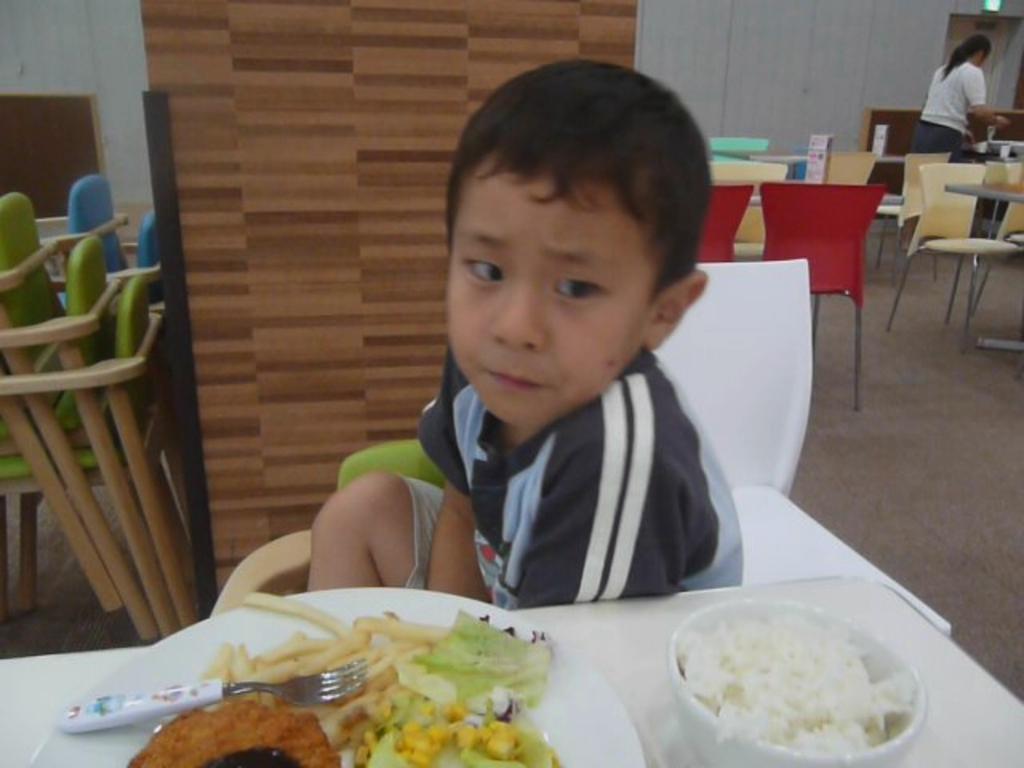Could you give a brief overview of what you see in this image? In this image I can see a woman and a child. The woman is standing on the floor and the child is sitting on a chair in front of a table. I can also see there are few chairs and tables on the floor, On the table we have food, cup, plate and other objects on it. 